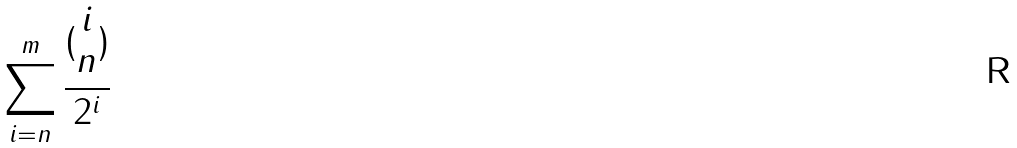Convert formula to latex. <formula><loc_0><loc_0><loc_500><loc_500>\sum _ { i = n } ^ { m } \frac { ( \begin{matrix} i \\ n \end{matrix} ) } { 2 ^ { i } }</formula> 